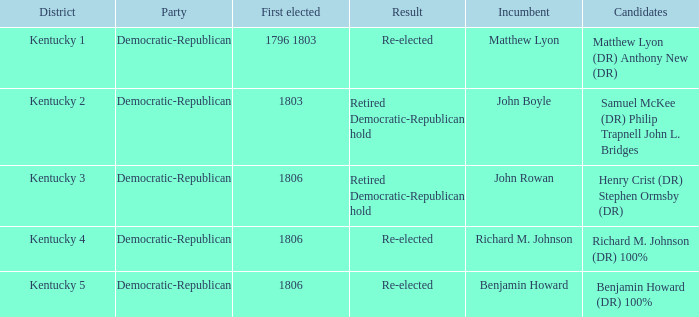Name the number of party for kentucky 1 1.0. 